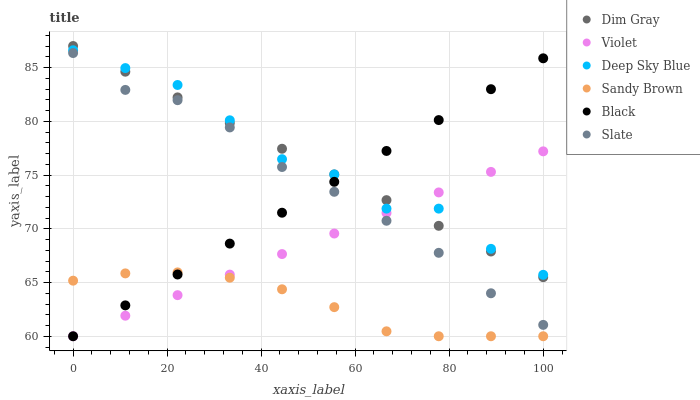Does Sandy Brown have the minimum area under the curve?
Answer yes or no. Yes. Does Deep Sky Blue have the maximum area under the curve?
Answer yes or no. Yes. Does Slate have the minimum area under the curve?
Answer yes or no. No. Does Slate have the maximum area under the curve?
Answer yes or no. No. Is Black the smoothest?
Answer yes or no. Yes. Is Deep Sky Blue the roughest?
Answer yes or no. Yes. Is Slate the smoothest?
Answer yes or no. No. Is Slate the roughest?
Answer yes or no. No. Does Black have the lowest value?
Answer yes or no. Yes. Does Slate have the lowest value?
Answer yes or no. No. Does Dim Gray have the highest value?
Answer yes or no. Yes. Does Slate have the highest value?
Answer yes or no. No. Is Sandy Brown less than Deep Sky Blue?
Answer yes or no. Yes. Is Slate greater than Sandy Brown?
Answer yes or no. Yes. Does Violet intersect Dim Gray?
Answer yes or no. Yes. Is Violet less than Dim Gray?
Answer yes or no. No. Is Violet greater than Dim Gray?
Answer yes or no. No. Does Sandy Brown intersect Deep Sky Blue?
Answer yes or no. No. 